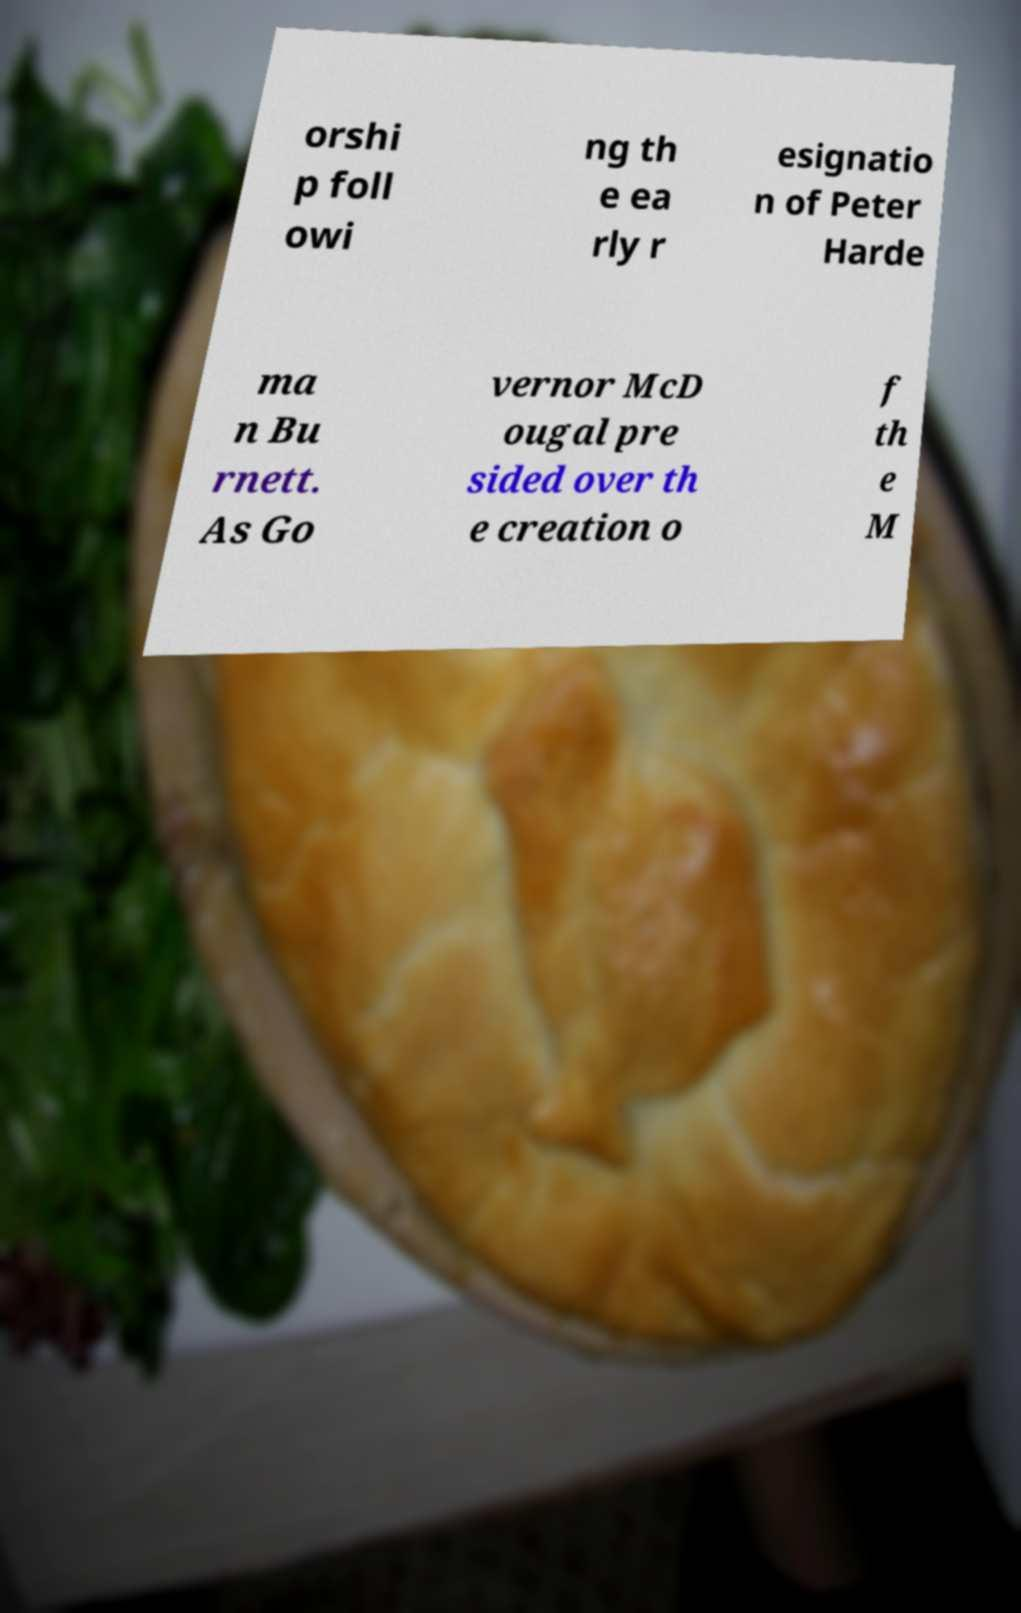Could you extract and type out the text from this image? orshi p foll owi ng th e ea rly r esignatio n of Peter Harde ma n Bu rnett. As Go vernor McD ougal pre sided over th e creation o f th e M 